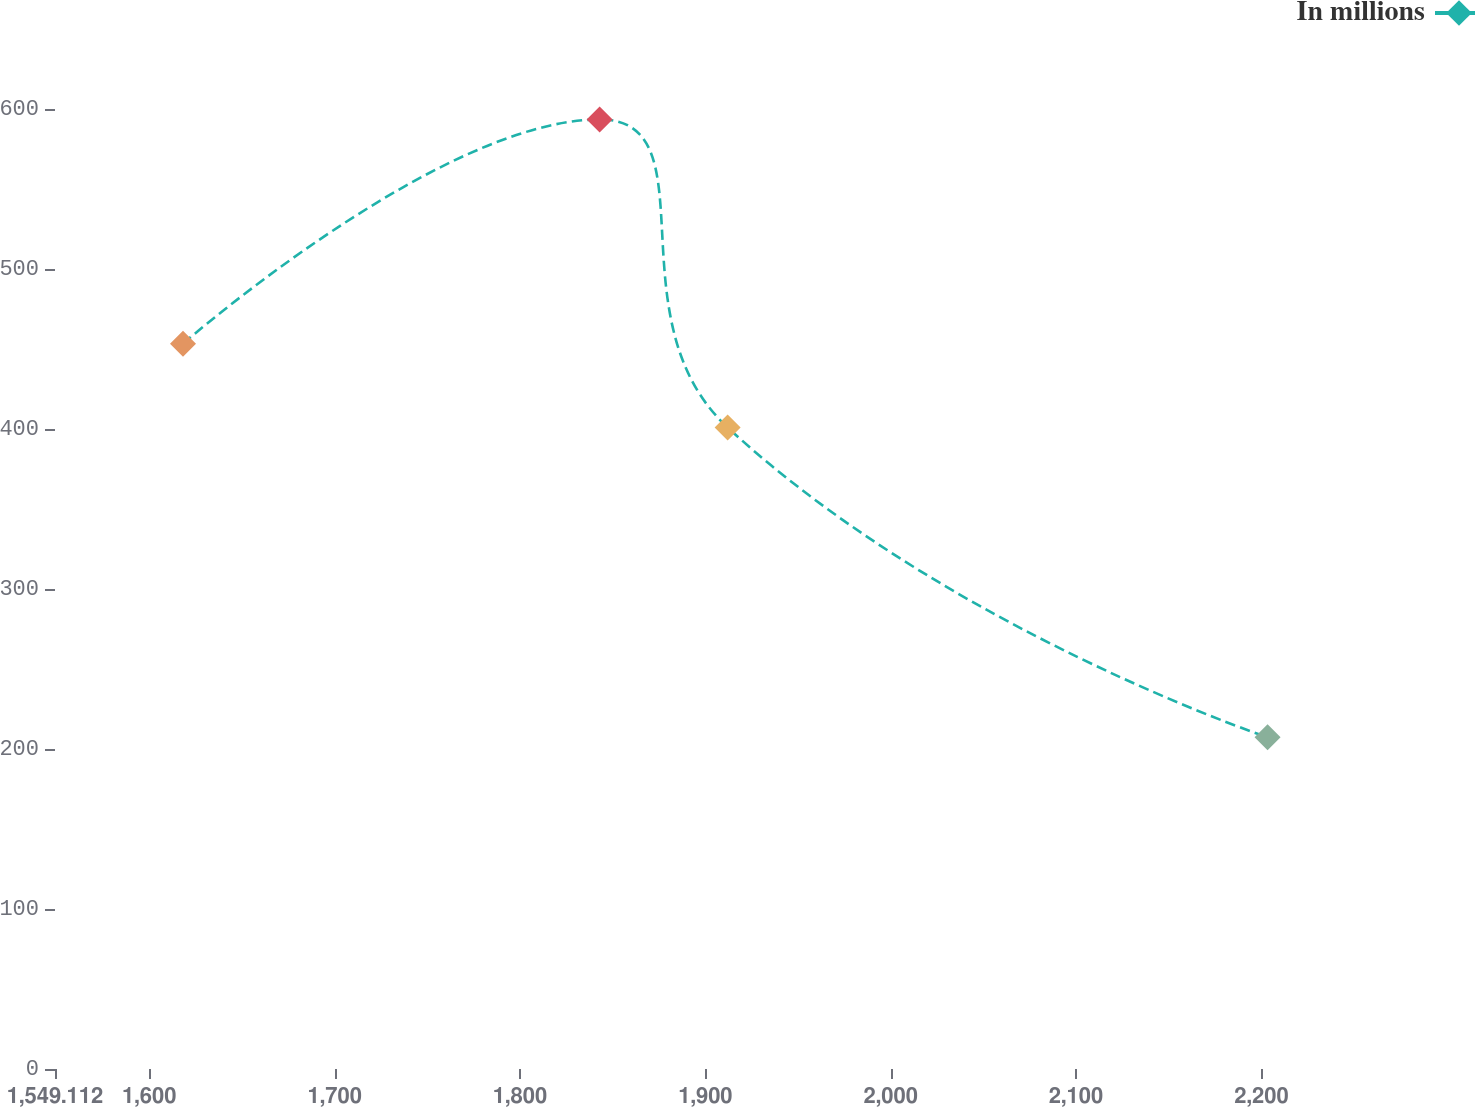Convert chart. <chart><loc_0><loc_0><loc_500><loc_500><line_chart><ecel><fcel>In millions<nl><fcel>1618.17<fcel>453.31<nl><fcel>1842.94<fcel>593.47<nl><fcel>1912<fcel>400.99<nl><fcel>2203.3<fcel>207.33<nl><fcel>2308.75<fcel>118.81<nl></chart> 